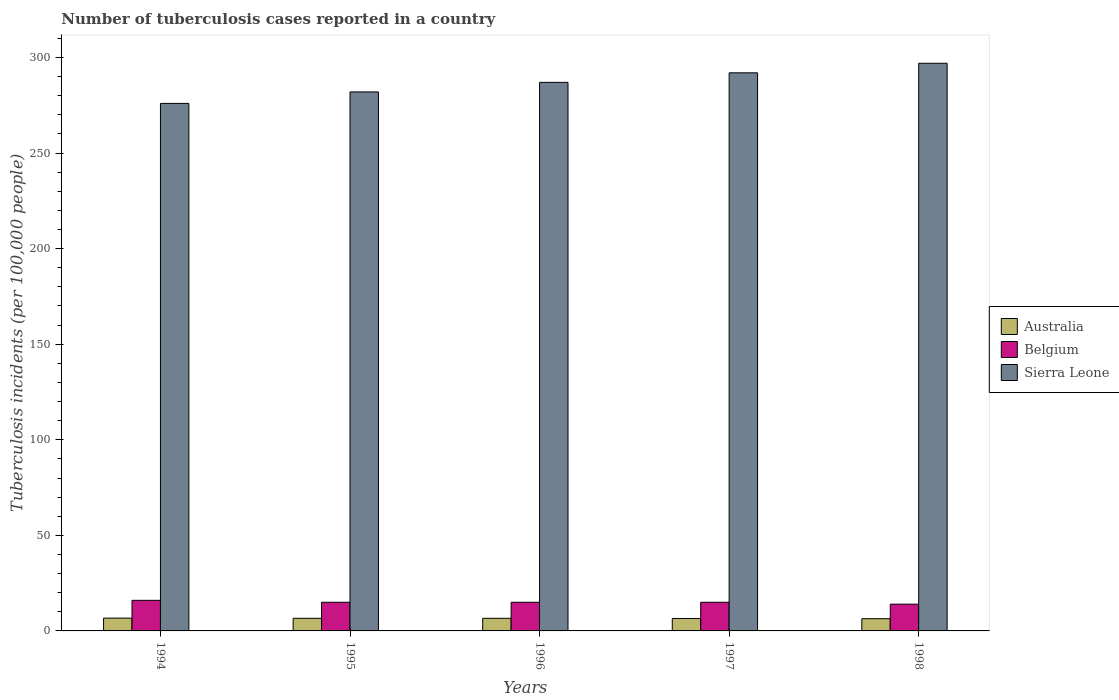How many bars are there on the 4th tick from the left?
Your response must be concise. 3. What is the label of the 3rd group of bars from the left?
Your answer should be very brief. 1996. What is the number of tuberculosis cases reported in in Belgium in 1996?
Your response must be concise. 15. Across all years, what is the maximum number of tuberculosis cases reported in in Sierra Leone?
Keep it short and to the point. 297. Across all years, what is the minimum number of tuberculosis cases reported in in Sierra Leone?
Offer a terse response. 276. In which year was the number of tuberculosis cases reported in in Sierra Leone maximum?
Provide a short and direct response. 1998. What is the total number of tuberculosis cases reported in in Sierra Leone in the graph?
Offer a very short reply. 1434. What is the difference between the number of tuberculosis cases reported in in Sierra Leone in 1997 and the number of tuberculosis cases reported in in Belgium in 1996?
Keep it short and to the point. 277. What is the average number of tuberculosis cases reported in in Sierra Leone per year?
Your answer should be very brief. 286.8. In the year 1995, what is the difference between the number of tuberculosis cases reported in in Sierra Leone and number of tuberculosis cases reported in in Belgium?
Make the answer very short. 267. In how many years, is the number of tuberculosis cases reported in in Australia greater than 80?
Offer a very short reply. 0. What is the ratio of the number of tuberculosis cases reported in in Sierra Leone in 1995 to that in 1997?
Offer a very short reply. 0.97. Is the number of tuberculosis cases reported in in Sierra Leone in 1994 less than that in 1998?
Offer a terse response. Yes. Is the difference between the number of tuberculosis cases reported in in Sierra Leone in 1995 and 1996 greater than the difference between the number of tuberculosis cases reported in in Belgium in 1995 and 1996?
Keep it short and to the point. No. What is the difference between the highest and the second highest number of tuberculosis cases reported in in Sierra Leone?
Give a very brief answer. 5. What is the difference between the highest and the lowest number of tuberculosis cases reported in in Australia?
Give a very brief answer. 0.3. What does the 1st bar from the left in 1995 represents?
Offer a very short reply. Australia. What does the 1st bar from the right in 1995 represents?
Offer a terse response. Sierra Leone. How many bars are there?
Keep it short and to the point. 15. Are all the bars in the graph horizontal?
Keep it short and to the point. No. What is the difference between two consecutive major ticks on the Y-axis?
Your response must be concise. 50. Are the values on the major ticks of Y-axis written in scientific E-notation?
Give a very brief answer. No. Where does the legend appear in the graph?
Make the answer very short. Center right. How many legend labels are there?
Give a very brief answer. 3. What is the title of the graph?
Make the answer very short. Number of tuberculosis cases reported in a country. Does "Suriname" appear as one of the legend labels in the graph?
Offer a terse response. No. What is the label or title of the X-axis?
Provide a succinct answer. Years. What is the label or title of the Y-axis?
Your answer should be compact. Tuberculosis incidents (per 100,0 people). What is the Tuberculosis incidents (per 100,000 people) of Sierra Leone in 1994?
Make the answer very short. 276. What is the Tuberculosis incidents (per 100,000 people) of Sierra Leone in 1995?
Your response must be concise. 282. What is the Tuberculosis incidents (per 100,000 people) in Australia in 1996?
Your answer should be very brief. 6.6. What is the Tuberculosis incidents (per 100,000 people) in Sierra Leone in 1996?
Make the answer very short. 287. What is the Tuberculosis incidents (per 100,000 people) of Belgium in 1997?
Offer a terse response. 15. What is the Tuberculosis incidents (per 100,000 people) in Sierra Leone in 1997?
Your answer should be very brief. 292. What is the Tuberculosis incidents (per 100,000 people) of Sierra Leone in 1998?
Provide a short and direct response. 297. Across all years, what is the maximum Tuberculosis incidents (per 100,000 people) of Australia?
Give a very brief answer. 6.7. Across all years, what is the maximum Tuberculosis incidents (per 100,000 people) of Sierra Leone?
Your answer should be very brief. 297. Across all years, what is the minimum Tuberculosis incidents (per 100,000 people) of Belgium?
Your response must be concise. 14. Across all years, what is the minimum Tuberculosis incidents (per 100,000 people) in Sierra Leone?
Offer a very short reply. 276. What is the total Tuberculosis incidents (per 100,000 people) of Australia in the graph?
Your answer should be compact. 32.8. What is the total Tuberculosis incidents (per 100,000 people) in Belgium in the graph?
Provide a short and direct response. 75. What is the total Tuberculosis incidents (per 100,000 people) in Sierra Leone in the graph?
Provide a succinct answer. 1434. What is the difference between the Tuberculosis incidents (per 100,000 people) in Belgium in 1994 and that in 1995?
Offer a terse response. 1. What is the difference between the Tuberculosis incidents (per 100,000 people) of Australia in 1994 and that in 1996?
Ensure brevity in your answer.  0.1. What is the difference between the Tuberculosis incidents (per 100,000 people) of Belgium in 1994 and that in 1996?
Ensure brevity in your answer.  1. What is the difference between the Tuberculosis incidents (per 100,000 people) of Sierra Leone in 1994 and that in 1996?
Keep it short and to the point. -11. What is the difference between the Tuberculosis incidents (per 100,000 people) in Australia in 1994 and that in 1997?
Your answer should be compact. 0.2. What is the difference between the Tuberculosis incidents (per 100,000 people) of Belgium in 1994 and that in 1997?
Keep it short and to the point. 1. What is the difference between the Tuberculosis incidents (per 100,000 people) in Australia in 1994 and that in 1998?
Give a very brief answer. 0.3. What is the difference between the Tuberculosis incidents (per 100,000 people) in Sierra Leone in 1994 and that in 1998?
Your answer should be very brief. -21. What is the difference between the Tuberculosis incidents (per 100,000 people) of Sierra Leone in 1995 and that in 1996?
Keep it short and to the point. -5. What is the difference between the Tuberculosis incidents (per 100,000 people) of Sierra Leone in 1995 and that in 1997?
Your response must be concise. -10. What is the difference between the Tuberculosis incidents (per 100,000 people) in Australia in 1996 and that in 1997?
Your response must be concise. 0.1. What is the difference between the Tuberculosis incidents (per 100,000 people) of Belgium in 1996 and that in 1997?
Your answer should be compact. 0. What is the difference between the Tuberculosis incidents (per 100,000 people) of Australia in 1996 and that in 1998?
Ensure brevity in your answer.  0.2. What is the difference between the Tuberculosis incidents (per 100,000 people) of Sierra Leone in 1996 and that in 1998?
Your answer should be very brief. -10. What is the difference between the Tuberculosis incidents (per 100,000 people) in Sierra Leone in 1997 and that in 1998?
Offer a terse response. -5. What is the difference between the Tuberculosis incidents (per 100,000 people) of Australia in 1994 and the Tuberculosis incidents (per 100,000 people) of Belgium in 1995?
Provide a succinct answer. -8.3. What is the difference between the Tuberculosis incidents (per 100,000 people) in Australia in 1994 and the Tuberculosis incidents (per 100,000 people) in Sierra Leone in 1995?
Offer a very short reply. -275.3. What is the difference between the Tuberculosis incidents (per 100,000 people) of Belgium in 1994 and the Tuberculosis incidents (per 100,000 people) of Sierra Leone in 1995?
Give a very brief answer. -266. What is the difference between the Tuberculosis incidents (per 100,000 people) of Australia in 1994 and the Tuberculosis incidents (per 100,000 people) of Belgium in 1996?
Provide a succinct answer. -8.3. What is the difference between the Tuberculosis incidents (per 100,000 people) in Australia in 1994 and the Tuberculosis incidents (per 100,000 people) in Sierra Leone in 1996?
Ensure brevity in your answer.  -280.3. What is the difference between the Tuberculosis incidents (per 100,000 people) of Belgium in 1994 and the Tuberculosis incidents (per 100,000 people) of Sierra Leone in 1996?
Make the answer very short. -271. What is the difference between the Tuberculosis incidents (per 100,000 people) in Australia in 1994 and the Tuberculosis incidents (per 100,000 people) in Belgium in 1997?
Provide a short and direct response. -8.3. What is the difference between the Tuberculosis incidents (per 100,000 people) of Australia in 1994 and the Tuberculosis incidents (per 100,000 people) of Sierra Leone in 1997?
Provide a succinct answer. -285.3. What is the difference between the Tuberculosis incidents (per 100,000 people) in Belgium in 1994 and the Tuberculosis incidents (per 100,000 people) in Sierra Leone in 1997?
Make the answer very short. -276. What is the difference between the Tuberculosis incidents (per 100,000 people) of Australia in 1994 and the Tuberculosis incidents (per 100,000 people) of Belgium in 1998?
Ensure brevity in your answer.  -7.3. What is the difference between the Tuberculosis incidents (per 100,000 people) in Australia in 1994 and the Tuberculosis incidents (per 100,000 people) in Sierra Leone in 1998?
Keep it short and to the point. -290.3. What is the difference between the Tuberculosis incidents (per 100,000 people) of Belgium in 1994 and the Tuberculosis incidents (per 100,000 people) of Sierra Leone in 1998?
Your answer should be compact. -281. What is the difference between the Tuberculosis incidents (per 100,000 people) of Australia in 1995 and the Tuberculosis incidents (per 100,000 people) of Sierra Leone in 1996?
Give a very brief answer. -280.4. What is the difference between the Tuberculosis incidents (per 100,000 people) of Belgium in 1995 and the Tuberculosis incidents (per 100,000 people) of Sierra Leone in 1996?
Keep it short and to the point. -272. What is the difference between the Tuberculosis incidents (per 100,000 people) in Australia in 1995 and the Tuberculosis incidents (per 100,000 people) in Belgium in 1997?
Make the answer very short. -8.4. What is the difference between the Tuberculosis incidents (per 100,000 people) of Australia in 1995 and the Tuberculosis incidents (per 100,000 people) of Sierra Leone in 1997?
Provide a short and direct response. -285.4. What is the difference between the Tuberculosis incidents (per 100,000 people) in Belgium in 1995 and the Tuberculosis incidents (per 100,000 people) in Sierra Leone in 1997?
Your answer should be very brief. -277. What is the difference between the Tuberculosis incidents (per 100,000 people) of Australia in 1995 and the Tuberculosis incidents (per 100,000 people) of Sierra Leone in 1998?
Provide a short and direct response. -290.4. What is the difference between the Tuberculosis incidents (per 100,000 people) of Belgium in 1995 and the Tuberculosis incidents (per 100,000 people) of Sierra Leone in 1998?
Your answer should be compact. -282. What is the difference between the Tuberculosis incidents (per 100,000 people) of Australia in 1996 and the Tuberculosis incidents (per 100,000 people) of Belgium in 1997?
Your answer should be very brief. -8.4. What is the difference between the Tuberculosis incidents (per 100,000 people) of Australia in 1996 and the Tuberculosis incidents (per 100,000 people) of Sierra Leone in 1997?
Provide a succinct answer. -285.4. What is the difference between the Tuberculosis incidents (per 100,000 people) in Belgium in 1996 and the Tuberculosis incidents (per 100,000 people) in Sierra Leone in 1997?
Your answer should be compact. -277. What is the difference between the Tuberculosis incidents (per 100,000 people) in Australia in 1996 and the Tuberculosis incidents (per 100,000 people) in Sierra Leone in 1998?
Offer a terse response. -290.4. What is the difference between the Tuberculosis incidents (per 100,000 people) of Belgium in 1996 and the Tuberculosis incidents (per 100,000 people) of Sierra Leone in 1998?
Offer a terse response. -282. What is the difference between the Tuberculosis incidents (per 100,000 people) of Australia in 1997 and the Tuberculosis incidents (per 100,000 people) of Sierra Leone in 1998?
Keep it short and to the point. -290.5. What is the difference between the Tuberculosis incidents (per 100,000 people) of Belgium in 1997 and the Tuberculosis incidents (per 100,000 people) of Sierra Leone in 1998?
Ensure brevity in your answer.  -282. What is the average Tuberculosis incidents (per 100,000 people) of Australia per year?
Your answer should be compact. 6.56. What is the average Tuberculosis incidents (per 100,000 people) of Belgium per year?
Give a very brief answer. 15. What is the average Tuberculosis incidents (per 100,000 people) of Sierra Leone per year?
Provide a short and direct response. 286.8. In the year 1994, what is the difference between the Tuberculosis incidents (per 100,000 people) in Australia and Tuberculosis incidents (per 100,000 people) in Belgium?
Ensure brevity in your answer.  -9.3. In the year 1994, what is the difference between the Tuberculosis incidents (per 100,000 people) of Australia and Tuberculosis incidents (per 100,000 people) of Sierra Leone?
Give a very brief answer. -269.3. In the year 1994, what is the difference between the Tuberculosis incidents (per 100,000 people) of Belgium and Tuberculosis incidents (per 100,000 people) of Sierra Leone?
Give a very brief answer. -260. In the year 1995, what is the difference between the Tuberculosis incidents (per 100,000 people) of Australia and Tuberculosis incidents (per 100,000 people) of Belgium?
Provide a short and direct response. -8.4. In the year 1995, what is the difference between the Tuberculosis incidents (per 100,000 people) of Australia and Tuberculosis incidents (per 100,000 people) of Sierra Leone?
Provide a succinct answer. -275.4. In the year 1995, what is the difference between the Tuberculosis incidents (per 100,000 people) of Belgium and Tuberculosis incidents (per 100,000 people) of Sierra Leone?
Provide a short and direct response. -267. In the year 1996, what is the difference between the Tuberculosis incidents (per 100,000 people) in Australia and Tuberculosis incidents (per 100,000 people) in Belgium?
Keep it short and to the point. -8.4. In the year 1996, what is the difference between the Tuberculosis incidents (per 100,000 people) in Australia and Tuberculosis incidents (per 100,000 people) in Sierra Leone?
Offer a very short reply. -280.4. In the year 1996, what is the difference between the Tuberculosis incidents (per 100,000 people) in Belgium and Tuberculosis incidents (per 100,000 people) in Sierra Leone?
Ensure brevity in your answer.  -272. In the year 1997, what is the difference between the Tuberculosis incidents (per 100,000 people) of Australia and Tuberculosis incidents (per 100,000 people) of Sierra Leone?
Offer a very short reply. -285.5. In the year 1997, what is the difference between the Tuberculosis incidents (per 100,000 people) in Belgium and Tuberculosis incidents (per 100,000 people) in Sierra Leone?
Your response must be concise. -277. In the year 1998, what is the difference between the Tuberculosis incidents (per 100,000 people) of Australia and Tuberculosis incidents (per 100,000 people) of Sierra Leone?
Your answer should be very brief. -290.6. In the year 1998, what is the difference between the Tuberculosis incidents (per 100,000 people) of Belgium and Tuberculosis incidents (per 100,000 people) of Sierra Leone?
Your answer should be very brief. -283. What is the ratio of the Tuberculosis incidents (per 100,000 people) of Australia in 1994 to that in 1995?
Keep it short and to the point. 1.02. What is the ratio of the Tuberculosis incidents (per 100,000 people) of Belgium in 1994 to that in 1995?
Your response must be concise. 1.07. What is the ratio of the Tuberculosis incidents (per 100,000 people) of Sierra Leone in 1994 to that in 1995?
Your answer should be very brief. 0.98. What is the ratio of the Tuberculosis incidents (per 100,000 people) in Australia in 1994 to that in 1996?
Keep it short and to the point. 1.02. What is the ratio of the Tuberculosis incidents (per 100,000 people) of Belgium in 1994 to that in 1996?
Keep it short and to the point. 1.07. What is the ratio of the Tuberculosis incidents (per 100,000 people) in Sierra Leone in 1994 to that in 1996?
Provide a short and direct response. 0.96. What is the ratio of the Tuberculosis incidents (per 100,000 people) of Australia in 1994 to that in 1997?
Provide a succinct answer. 1.03. What is the ratio of the Tuberculosis incidents (per 100,000 people) of Belgium in 1994 to that in 1997?
Keep it short and to the point. 1.07. What is the ratio of the Tuberculosis incidents (per 100,000 people) in Sierra Leone in 1994 to that in 1997?
Provide a succinct answer. 0.95. What is the ratio of the Tuberculosis incidents (per 100,000 people) of Australia in 1994 to that in 1998?
Your answer should be compact. 1.05. What is the ratio of the Tuberculosis incidents (per 100,000 people) of Belgium in 1994 to that in 1998?
Make the answer very short. 1.14. What is the ratio of the Tuberculosis incidents (per 100,000 people) of Sierra Leone in 1994 to that in 1998?
Your answer should be compact. 0.93. What is the ratio of the Tuberculosis incidents (per 100,000 people) in Australia in 1995 to that in 1996?
Give a very brief answer. 1. What is the ratio of the Tuberculosis incidents (per 100,000 people) in Sierra Leone in 1995 to that in 1996?
Offer a very short reply. 0.98. What is the ratio of the Tuberculosis incidents (per 100,000 people) of Australia in 1995 to that in 1997?
Offer a very short reply. 1.02. What is the ratio of the Tuberculosis incidents (per 100,000 people) in Sierra Leone in 1995 to that in 1997?
Offer a terse response. 0.97. What is the ratio of the Tuberculosis incidents (per 100,000 people) of Australia in 1995 to that in 1998?
Your answer should be compact. 1.03. What is the ratio of the Tuberculosis incidents (per 100,000 people) in Belgium in 1995 to that in 1998?
Make the answer very short. 1.07. What is the ratio of the Tuberculosis incidents (per 100,000 people) of Sierra Leone in 1995 to that in 1998?
Your response must be concise. 0.95. What is the ratio of the Tuberculosis incidents (per 100,000 people) of Australia in 1996 to that in 1997?
Keep it short and to the point. 1.02. What is the ratio of the Tuberculosis incidents (per 100,000 people) in Belgium in 1996 to that in 1997?
Keep it short and to the point. 1. What is the ratio of the Tuberculosis incidents (per 100,000 people) in Sierra Leone in 1996 to that in 1997?
Give a very brief answer. 0.98. What is the ratio of the Tuberculosis incidents (per 100,000 people) in Australia in 1996 to that in 1998?
Provide a short and direct response. 1.03. What is the ratio of the Tuberculosis incidents (per 100,000 people) of Belgium in 1996 to that in 1998?
Ensure brevity in your answer.  1.07. What is the ratio of the Tuberculosis incidents (per 100,000 people) of Sierra Leone in 1996 to that in 1998?
Keep it short and to the point. 0.97. What is the ratio of the Tuberculosis incidents (per 100,000 people) of Australia in 1997 to that in 1998?
Your answer should be compact. 1.02. What is the ratio of the Tuberculosis incidents (per 100,000 people) of Belgium in 1997 to that in 1998?
Keep it short and to the point. 1.07. What is the ratio of the Tuberculosis incidents (per 100,000 people) of Sierra Leone in 1997 to that in 1998?
Give a very brief answer. 0.98. What is the difference between the highest and the second highest Tuberculosis incidents (per 100,000 people) of Australia?
Ensure brevity in your answer.  0.1. What is the difference between the highest and the second highest Tuberculosis incidents (per 100,000 people) of Sierra Leone?
Make the answer very short. 5. What is the difference between the highest and the lowest Tuberculosis incidents (per 100,000 people) in Belgium?
Ensure brevity in your answer.  2. What is the difference between the highest and the lowest Tuberculosis incidents (per 100,000 people) of Sierra Leone?
Provide a short and direct response. 21. 